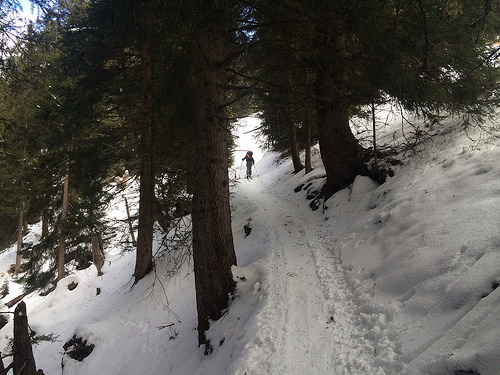<image>
Is there a skiier on the snow? Yes. Looking at the image, I can see the skiier is positioned on top of the snow, with the snow providing support. Is there a human behind the tree? Yes. From this viewpoint, the human is positioned behind the tree, with the tree partially or fully occluding the human. Is there a man next to the tree? No. The man is not positioned next to the tree. They are located in different areas of the scene. 